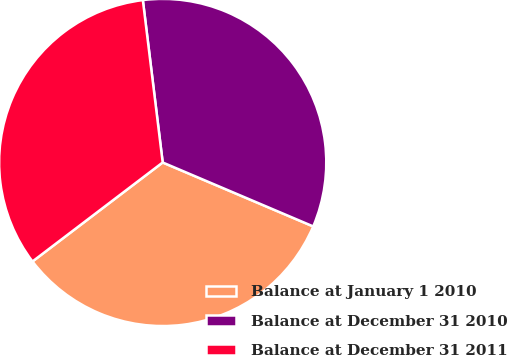<chart> <loc_0><loc_0><loc_500><loc_500><pie_chart><fcel>Balance at January 1 2010<fcel>Balance at December 31 2010<fcel>Balance at December 31 2011<nl><fcel>33.26%<fcel>33.33%<fcel>33.41%<nl></chart> 